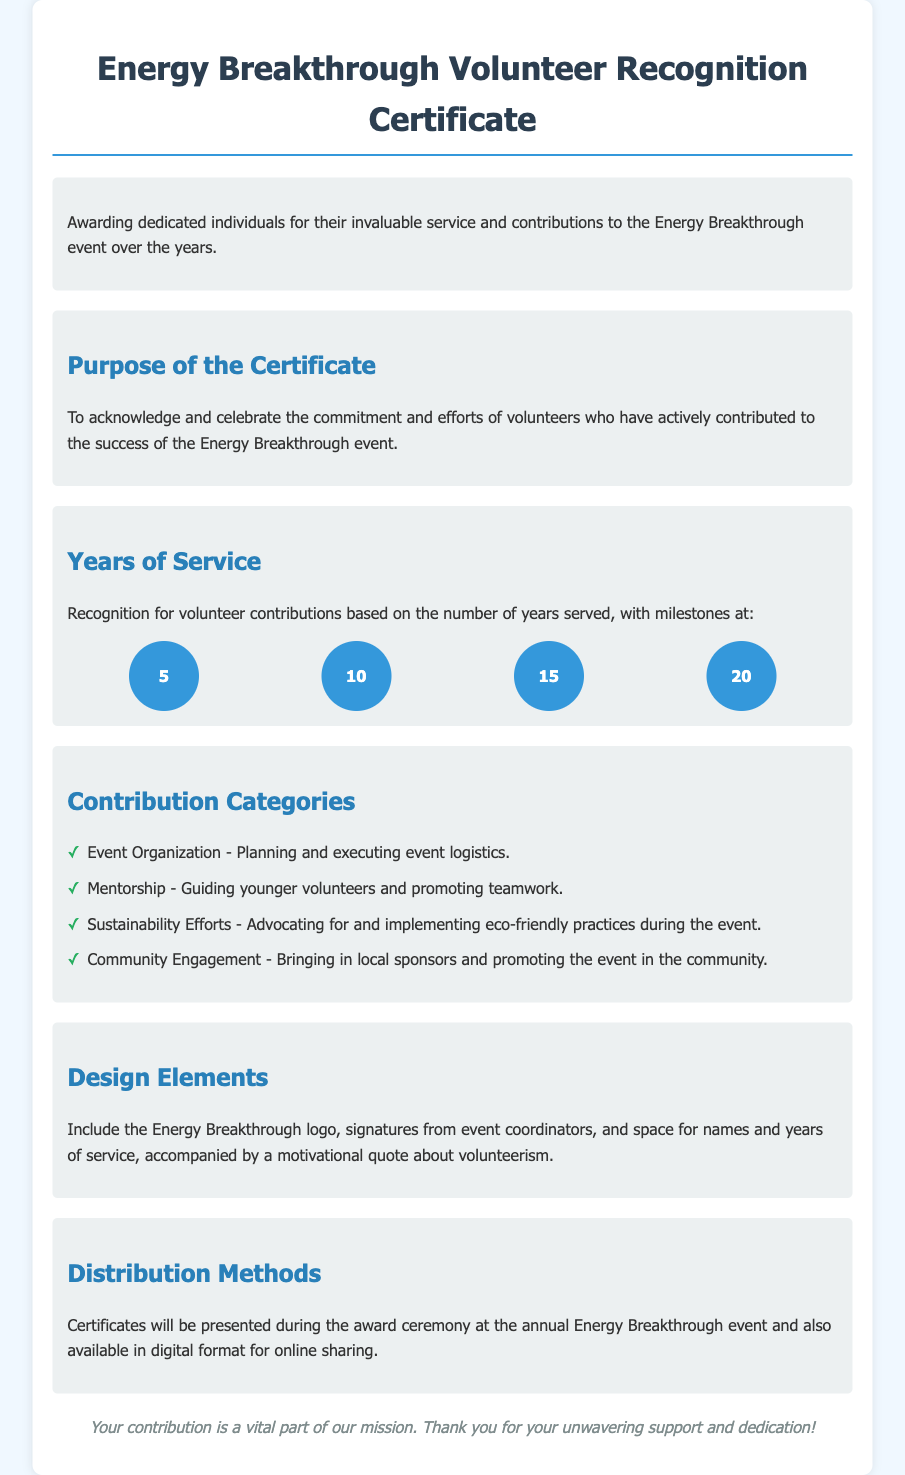what is the title of the certificate? The title of the certificate is stated at the top of the document as "Energy Breakthrough Volunteer Recognition Certificate."
Answer: Energy Breakthrough Volunteer Recognition Certificate how many years of service are recognized? The document lists milestones for years of service, which are 5, 10, 15, and 20 years.
Answer: 4 what is one category of contribution mentioned? One of the categories of contribution listed is "Event Organization."
Answer: Event Organization how are the certificates distributed? The distribution method for the certificates is mentioned as during the award ceremony and in digital format.
Answer: Award ceremony and digital format what color is the background of the document? The background color of the document is specified as light blue (#f0f8ff).
Answer: Light blue what is the purpose of the certificate? The purpose is stated as acknowledging and celebrating the commitment and efforts of volunteers.
Answer: Acknowledge and celebrate commitment who signs the certificates? The document mentions that signatures will come from event coordinators.
Answer: Event coordinators what shape is used to represent milestones in years of service? The document describes the milestones as being represented in circular shapes.
Answer: Circular shapes which quote is included in the design elements? The document indicates a motivational quote about volunteerism is included but does not specify the quote itself.
Answer: Motivational quote about volunteerism 